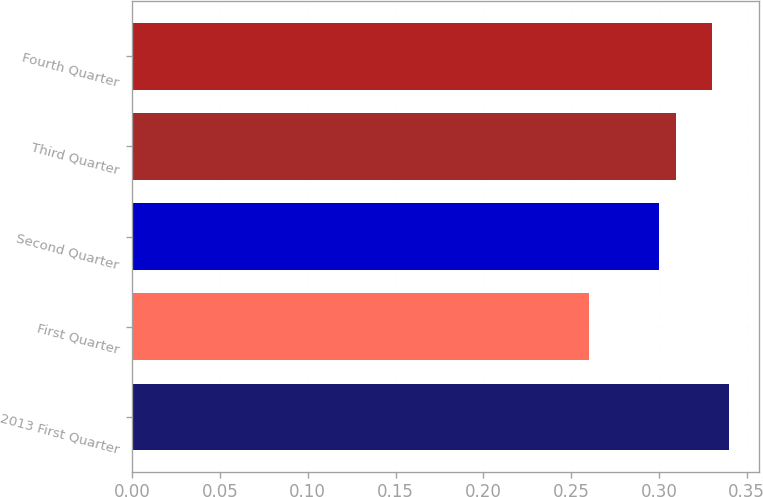Convert chart to OTSL. <chart><loc_0><loc_0><loc_500><loc_500><bar_chart><fcel>2013 First Quarter<fcel>First Quarter<fcel>Second Quarter<fcel>Third Quarter<fcel>Fourth Quarter<nl><fcel>0.34<fcel>0.26<fcel>0.3<fcel>0.31<fcel>0.33<nl></chart> 